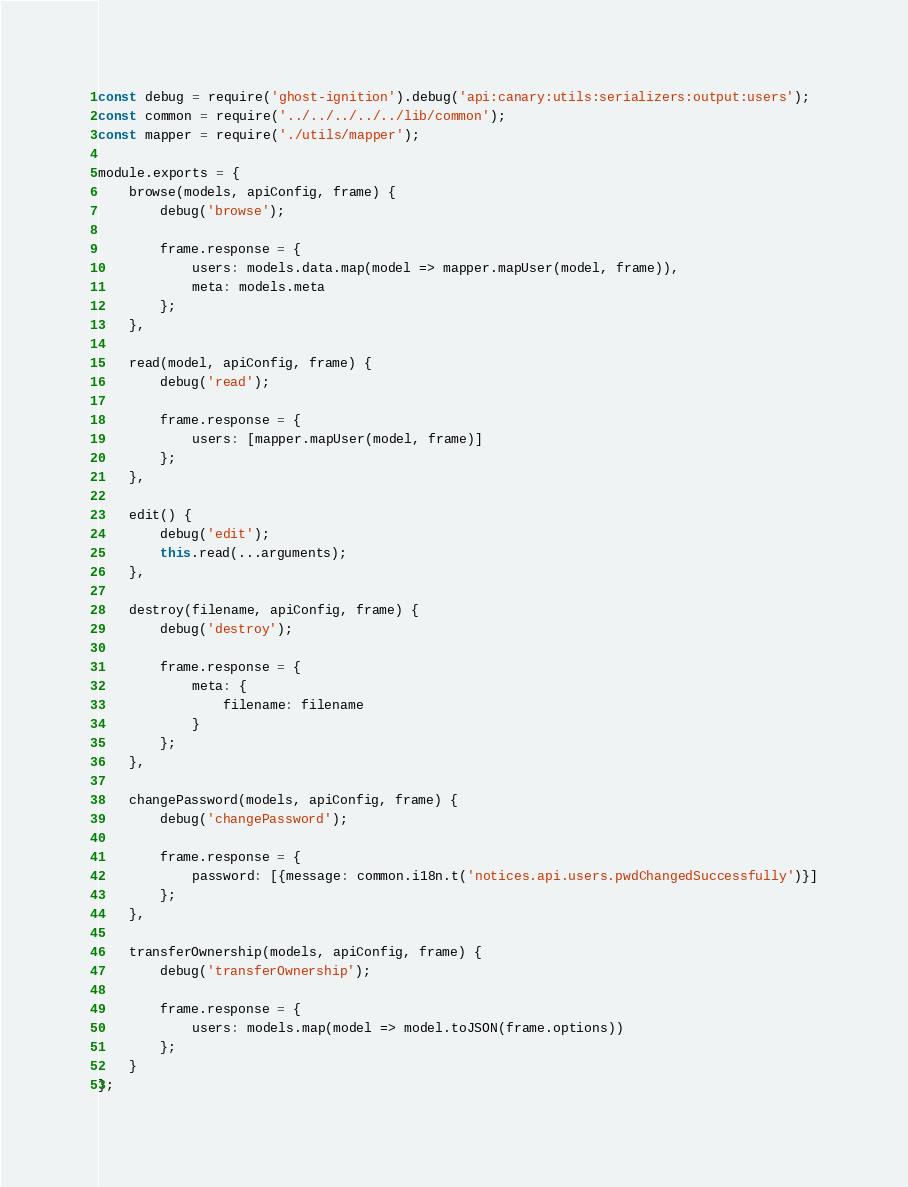<code> <loc_0><loc_0><loc_500><loc_500><_JavaScript_>const debug = require('ghost-ignition').debug('api:canary:utils:serializers:output:users');
const common = require('../../../../../lib/common');
const mapper = require('./utils/mapper');

module.exports = {
    browse(models, apiConfig, frame) {
        debug('browse');

        frame.response = {
            users: models.data.map(model => mapper.mapUser(model, frame)),
            meta: models.meta
        };
    },

    read(model, apiConfig, frame) {
        debug('read');

        frame.response = {
            users: [mapper.mapUser(model, frame)]
        };
    },

    edit() {
        debug('edit');
        this.read(...arguments);
    },

    destroy(filename, apiConfig, frame) {
        debug('destroy');

        frame.response = {
            meta: {
                filename: filename
            }
        };
    },

    changePassword(models, apiConfig, frame) {
        debug('changePassword');

        frame.response = {
            password: [{message: common.i18n.t('notices.api.users.pwdChangedSuccessfully')}]
        };
    },

    transferOwnership(models, apiConfig, frame) {
        debug('transferOwnership');

        frame.response = {
            users: models.map(model => model.toJSON(frame.options))
        };
    }
};
</code> 